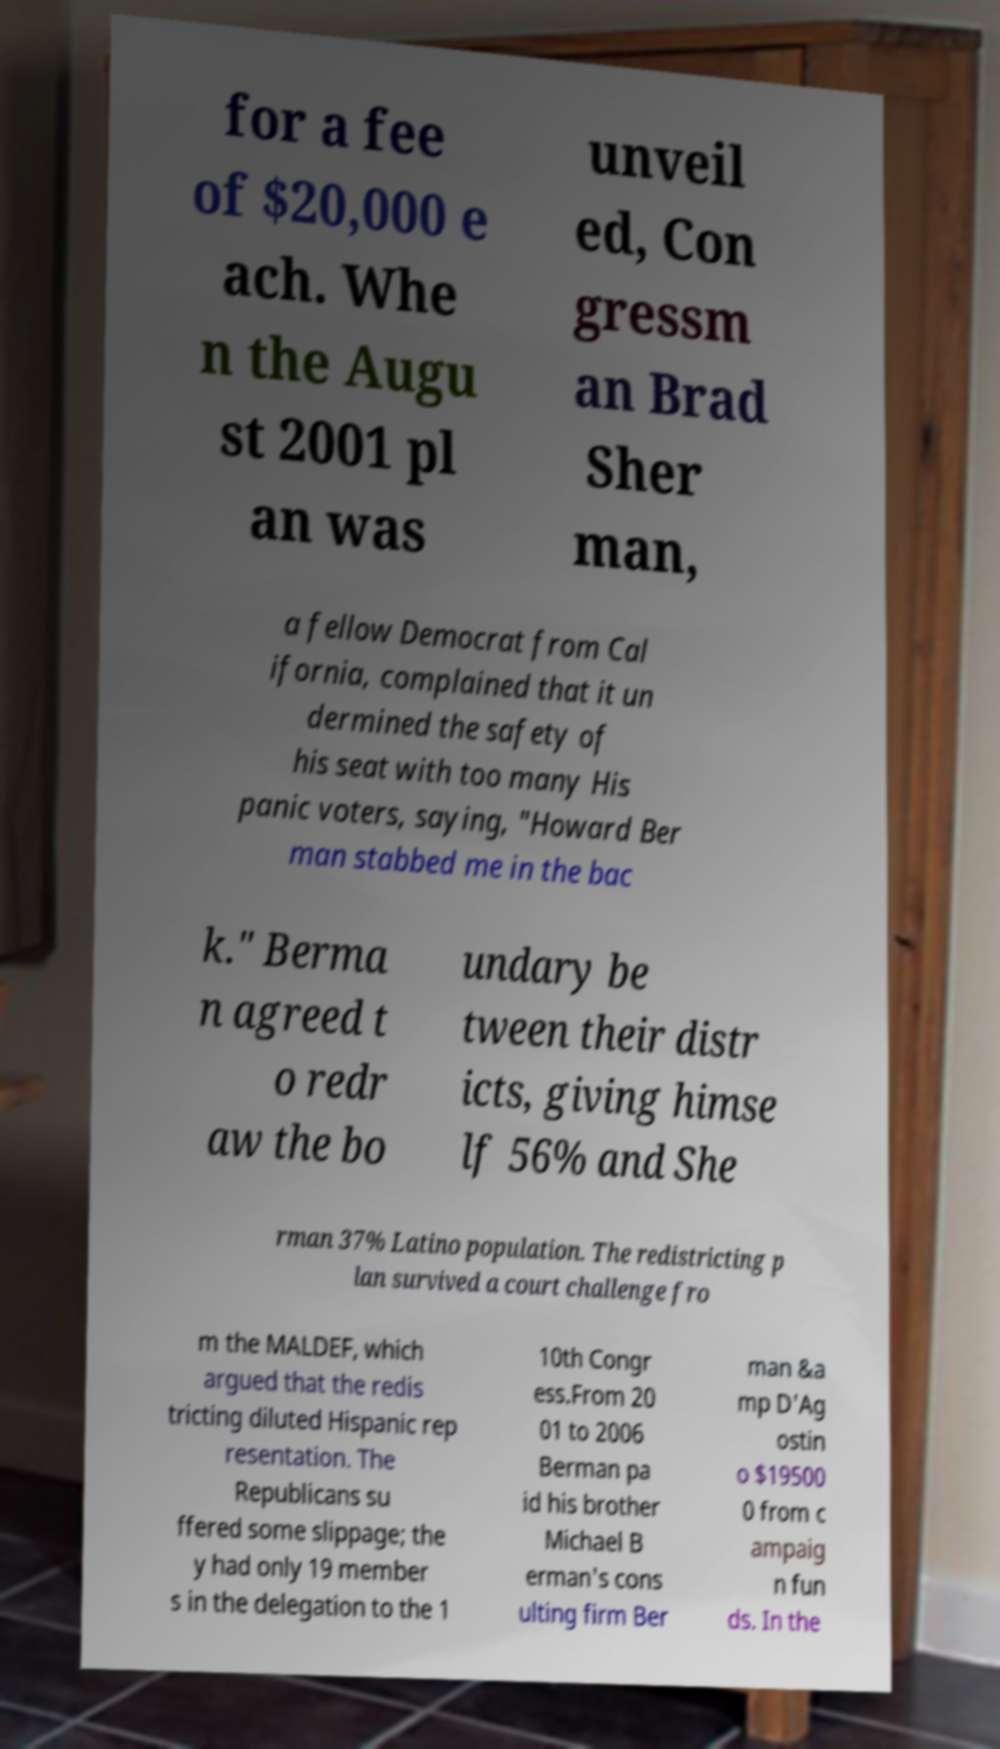Could you extract and type out the text from this image? for a fee of $20,000 e ach. Whe n the Augu st 2001 pl an was unveil ed, Con gressm an Brad Sher man, a fellow Democrat from Cal ifornia, complained that it un dermined the safety of his seat with too many His panic voters, saying, "Howard Ber man stabbed me in the bac k." Berma n agreed t o redr aw the bo undary be tween their distr icts, giving himse lf 56% and She rman 37% Latino population. The redistricting p lan survived a court challenge fro m the MALDEF, which argued that the redis tricting diluted Hispanic rep resentation. The Republicans su ffered some slippage; the y had only 19 member s in the delegation to the 1 10th Congr ess.From 20 01 to 2006 Berman pa id his brother Michael B erman's cons ulting firm Ber man &a mp D'Ag ostin o $19500 0 from c ampaig n fun ds. In the 